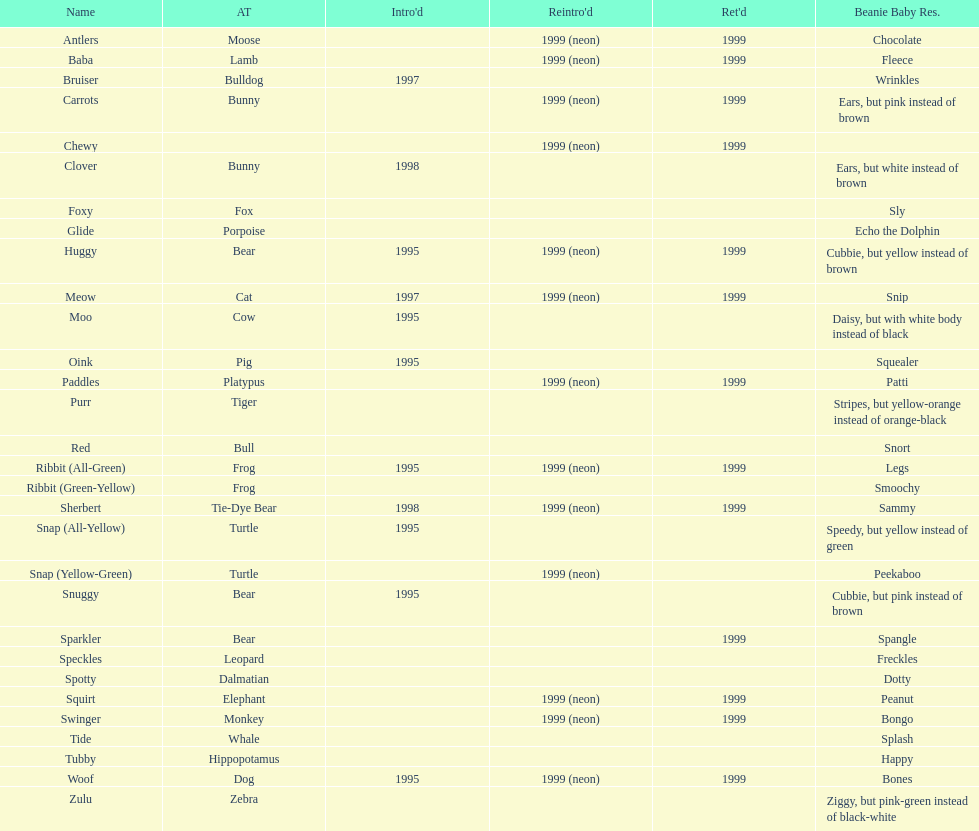What is the complete quantity of pillow pals that were brought back as a neon variant? 13. 